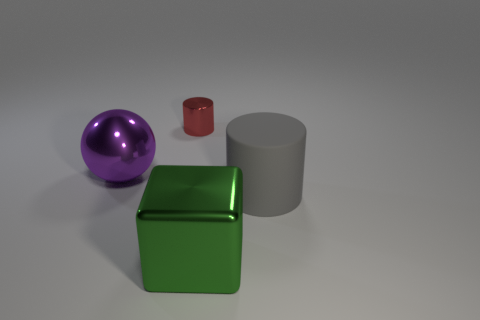Add 3 small red matte things. How many objects exist? 7 Subtract all blue blocks. Subtract all cylinders. How many objects are left? 2 Add 4 big objects. How many big objects are left? 7 Add 4 large purple matte cubes. How many large purple matte cubes exist? 4 Subtract 0 yellow cubes. How many objects are left? 4 